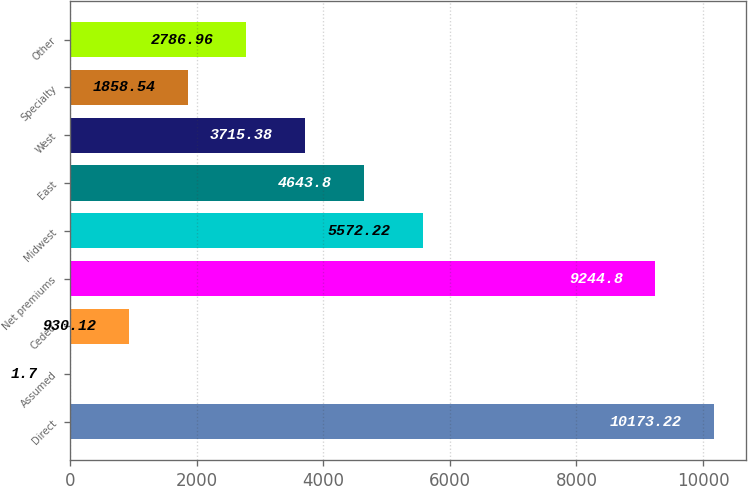Convert chart. <chart><loc_0><loc_0><loc_500><loc_500><bar_chart><fcel>Direct<fcel>Assumed<fcel>Ceded<fcel>Net premiums<fcel>Midwest<fcel>East<fcel>West<fcel>Specialty<fcel>Other<nl><fcel>10173.2<fcel>1.7<fcel>930.12<fcel>9244.8<fcel>5572.22<fcel>4643.8<fcel>3715.38<fcel>1858.54<fcel>2786.96<nl></chart> 